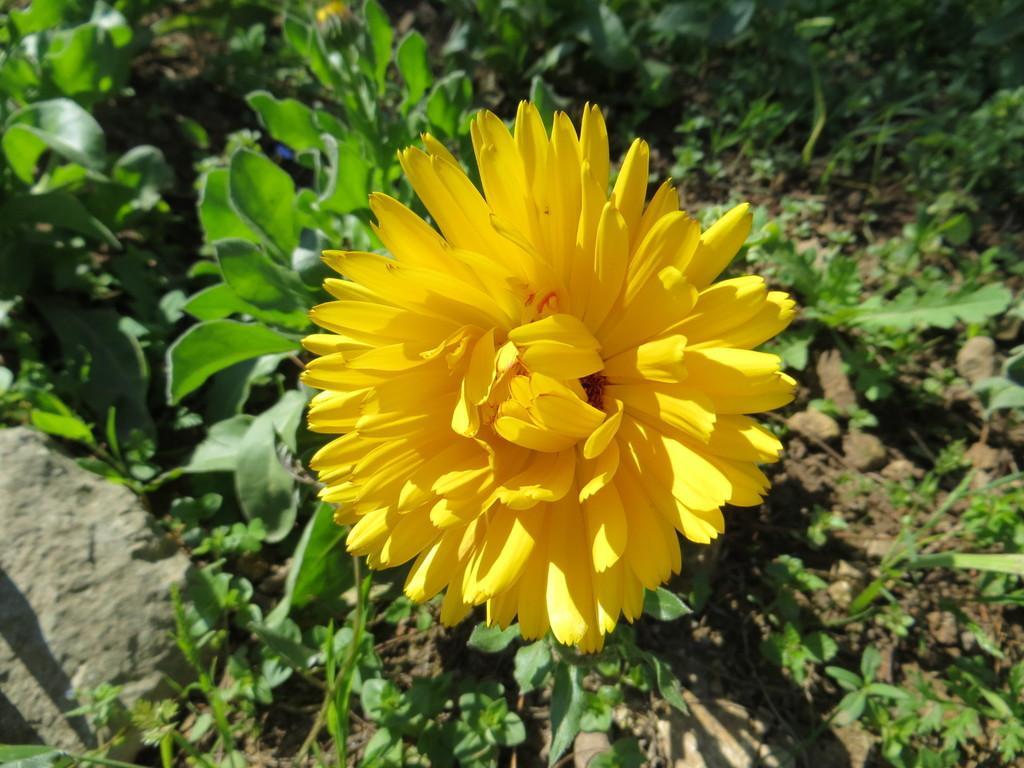Can you describe this image briefly? In this image I see a flower which is of yellow in color and I see number of plants and I see the mud and I see the stone over here. 